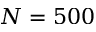Convert formula to latex. <formula><loc_0><loc_0><loc_500><loc_500>N = 5 0 0</formula> 